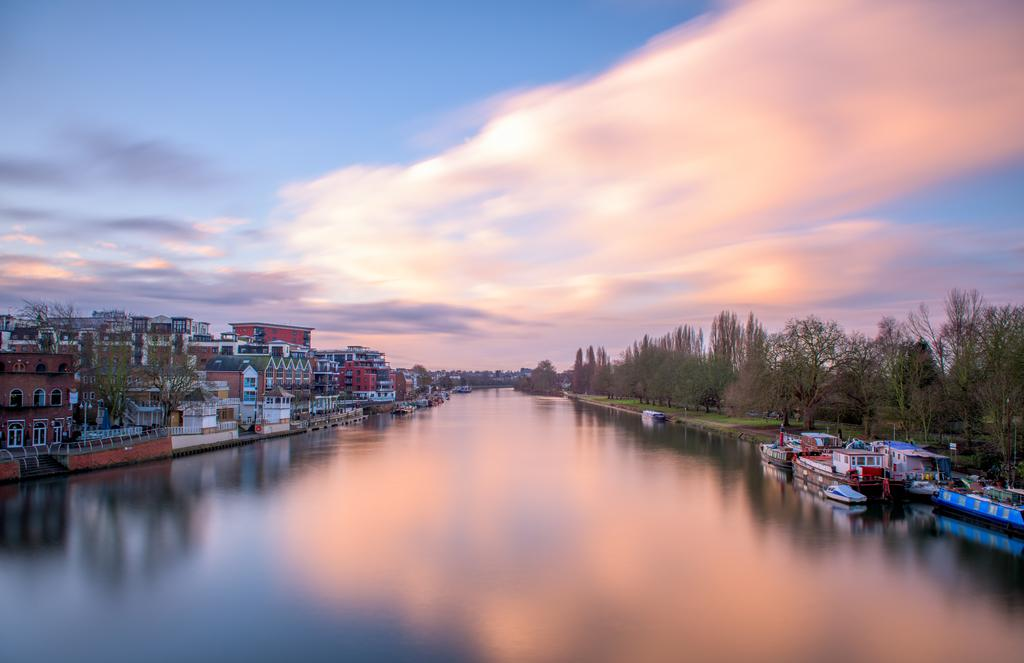What type of vegetation is on the right side of the image? There are trees on the right side of the image. What type of watercraft can be seen on the right side of the image? There are boats on the right side of the image. What is in the center of the image? There is a canal in the center of the image. What type of structures are on the left side of the image? There are buildings on the left side of the image. What type of vegetation is on the left side of the image? There are trees on the left side of the image. What is visible in the background and at the top of the image? The sky is visible in the background and at the top of the image. What type of iron is present in the image? There is no iron present in the image. Who is the achiever in the image? The image does not depict any individuals or achievements, so it is not possible to identify an achiever. 